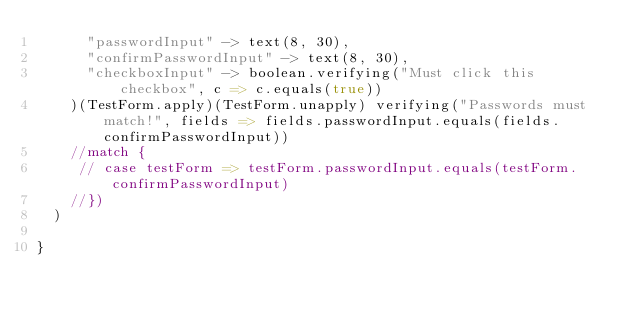<code> <loc_0><loc_0><loc_500><loc_500><_Scala_>      "passwordInput" -> text(8, 30),
      "confirmPasswordInput" -> text(8, 30),
      "checkboxInput" -> boolean.verifying("Must click this checkbox", c => c.equals(true))
    )(TestForm.apply)(TestForm.unapply) verifying("Passwords must match!", fields => fields.passwordInput.equals(fields.confirmPasswordInput))
    //match {
     // case testForm => testForm.passwordInput.equals(testForm.confirmPasswordInput)
    //})
  )

}

</code> 